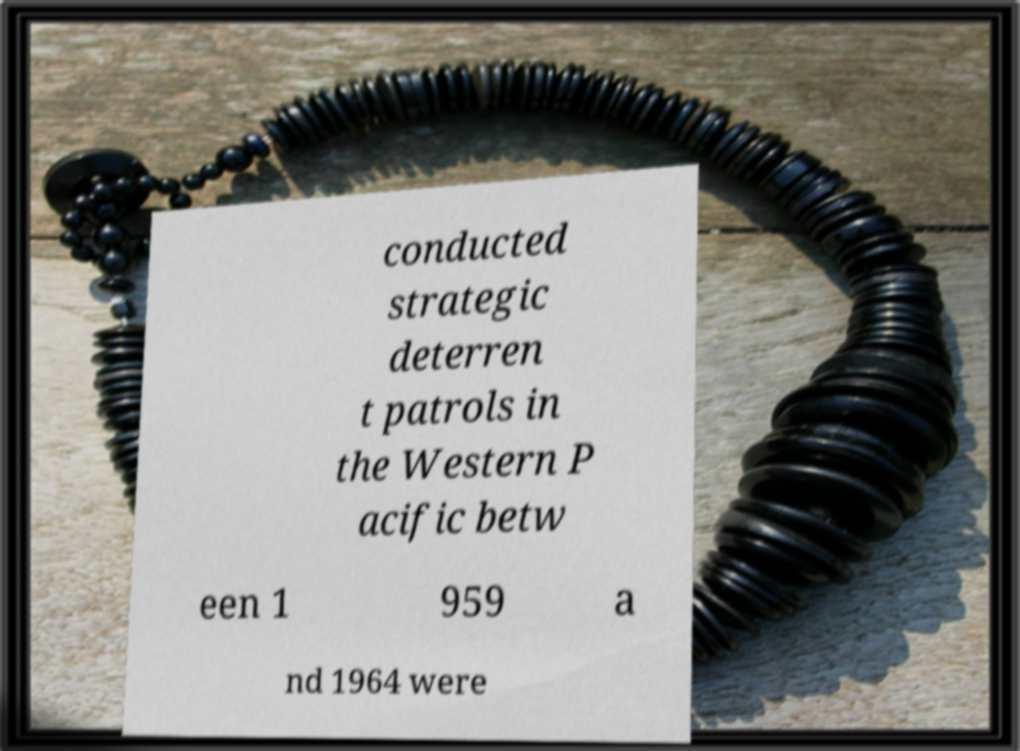For documentation purposes, I need the text within this image transcribed. Could you provide that? conducted strategic deterren t patrols in the Western P acific betw een 1 959 a nd 1964 were 